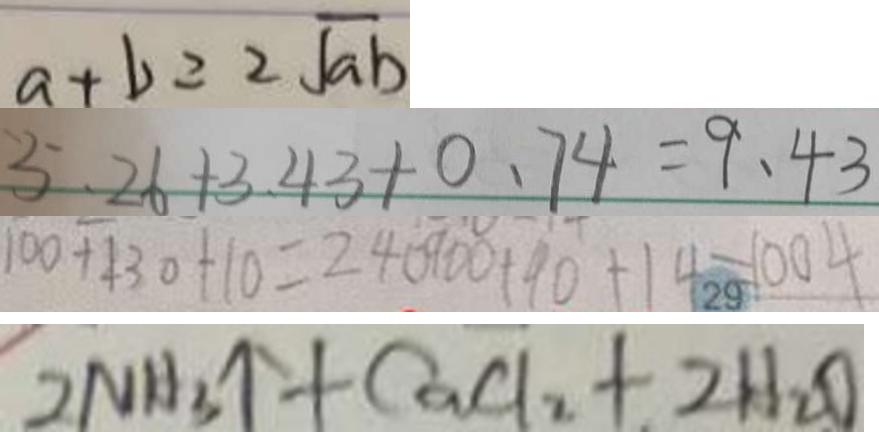<formula> <loc_0><loc_0><loc_500><loc_500>a + b = 2 \sqrt { a b } 
 5 . 2 6 + 3 . 4 3 + 0 . 7 4 = 9 . 4 3 
 1 0 0 + 1 3 0 + 1 0 = 2 4 0 9 0 0 + 9 0 + 1 4 = 1 0 0 4 
 2 N H _ { 3 } \uparrow + C a C l _ { 2 } + 2 H _ { 2 } O</formula> 